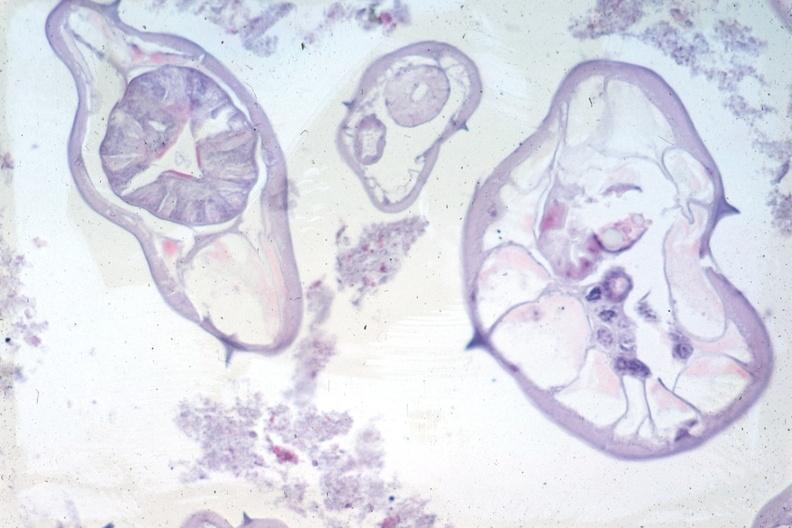s endocervical polyp present?
Answer the question using a single word or phrase. No 